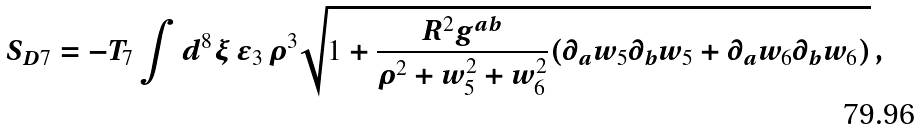<formula> <loc_0><loc_0><loc_500><loc_500>S _ { D 7 } = - T _ { 7 } \int d ^ { 8 } \xi \, \epsilon _ { 3 } \, \rho ^ { 3 } \sqrt { 1 + \frac { R ^ { 2 } g ^ { a b } } { \rho ^ { 2 } + w _ { 5 } ^ { 2 } + w _ { 6 } ^ { 2 } } ( \partial _ { a } w _ { 5 } \partial _ { b } w _ { 5 } + \partial _ { a } w _ { 6 } \partial _ { b } w _ { 6 } ) } \, ,</formula> 